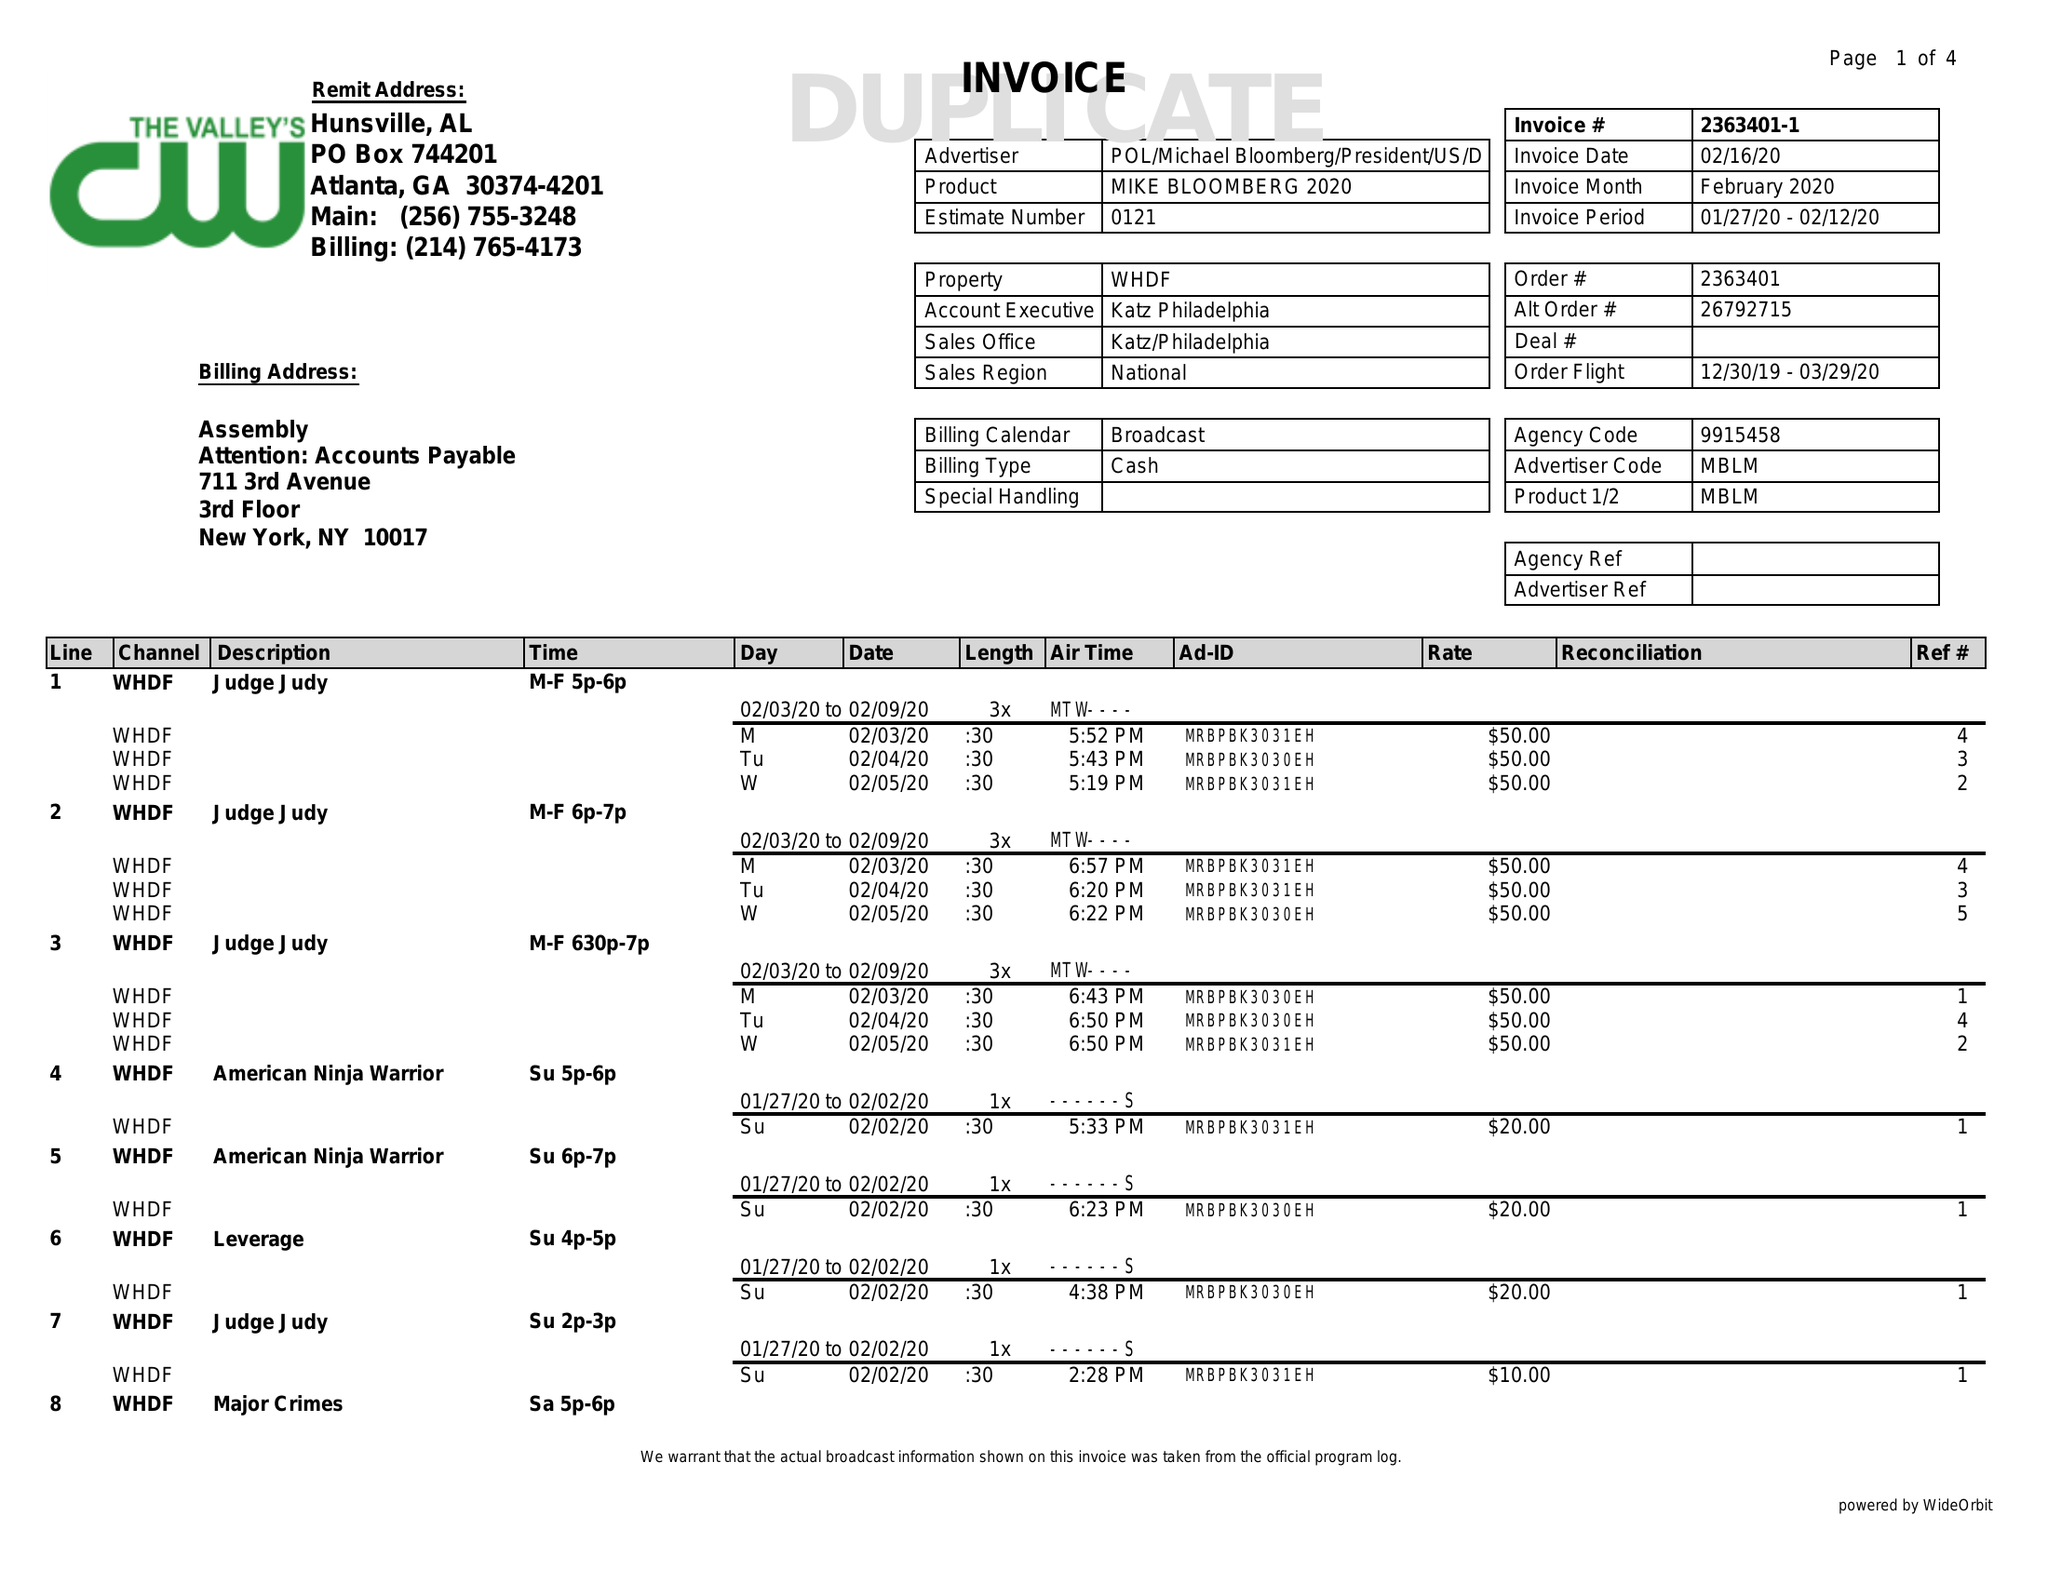What is the value for the advertiser?
Answer the question using a single word or phrase. POL/MICHAELBLOOMBERG/PRESIDENT/US/DEM 